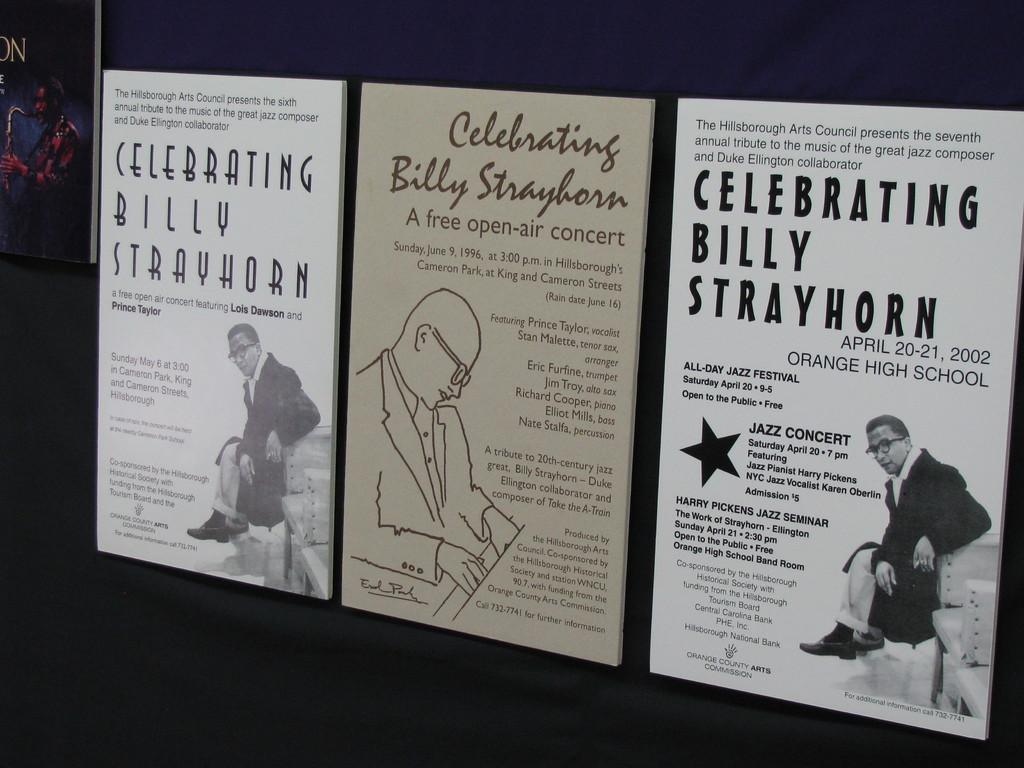<image>
Share a concise interpretation of the image provided. Concert posters are hung on a dark wall for a variety of concerts celebrating Billy Strayhorn. 